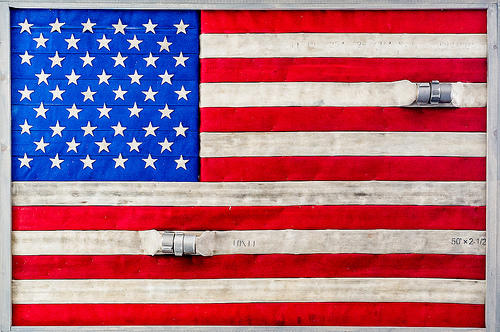<image>
Is the stars to the right of the strip? Yes. From this viewpoint, the stars is positioned to the right side relative to the strip. 